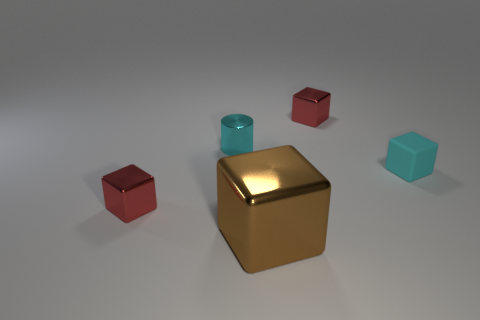Is there any other thing that is the same shape as the tiny cyan metallic thing?
Offer a terse response. No. Is there anything else that has the same size as the brown cube?
Give a very brief answer. No. What is the size of the metal cube that is both behind the large brown shiny cube and in front of the cyan metal cylinder?
Give a very brief answer. Small. There is a small red metal block behind the rubber object; is there a large thing that is to the right of it?
Your answer should be compact. No. There is a cylinder; how many metal objects are right of it?
Offer a very short reply. 2. The large object that is the same shape as the tiny cyan matte object is what color?
Give a very brief answer. Brown. Is the big brown thing that is in front of the small cyan rubber block made of the same material as the small red block that is on the left side of the big brown shiny thing?
Make the answer very short. Yes. There is a cylinder; does it have the same color as the small metal thing on the right side of the brown metal cube?
Provide a succinct answer. No. The object that is both right of the big brown metal block and to the left of the tiny cyan matte block has what shape?
Ensure brevity in your answer.  Cube. How many large rubber things are there?
Offer a very short reply. 0. 